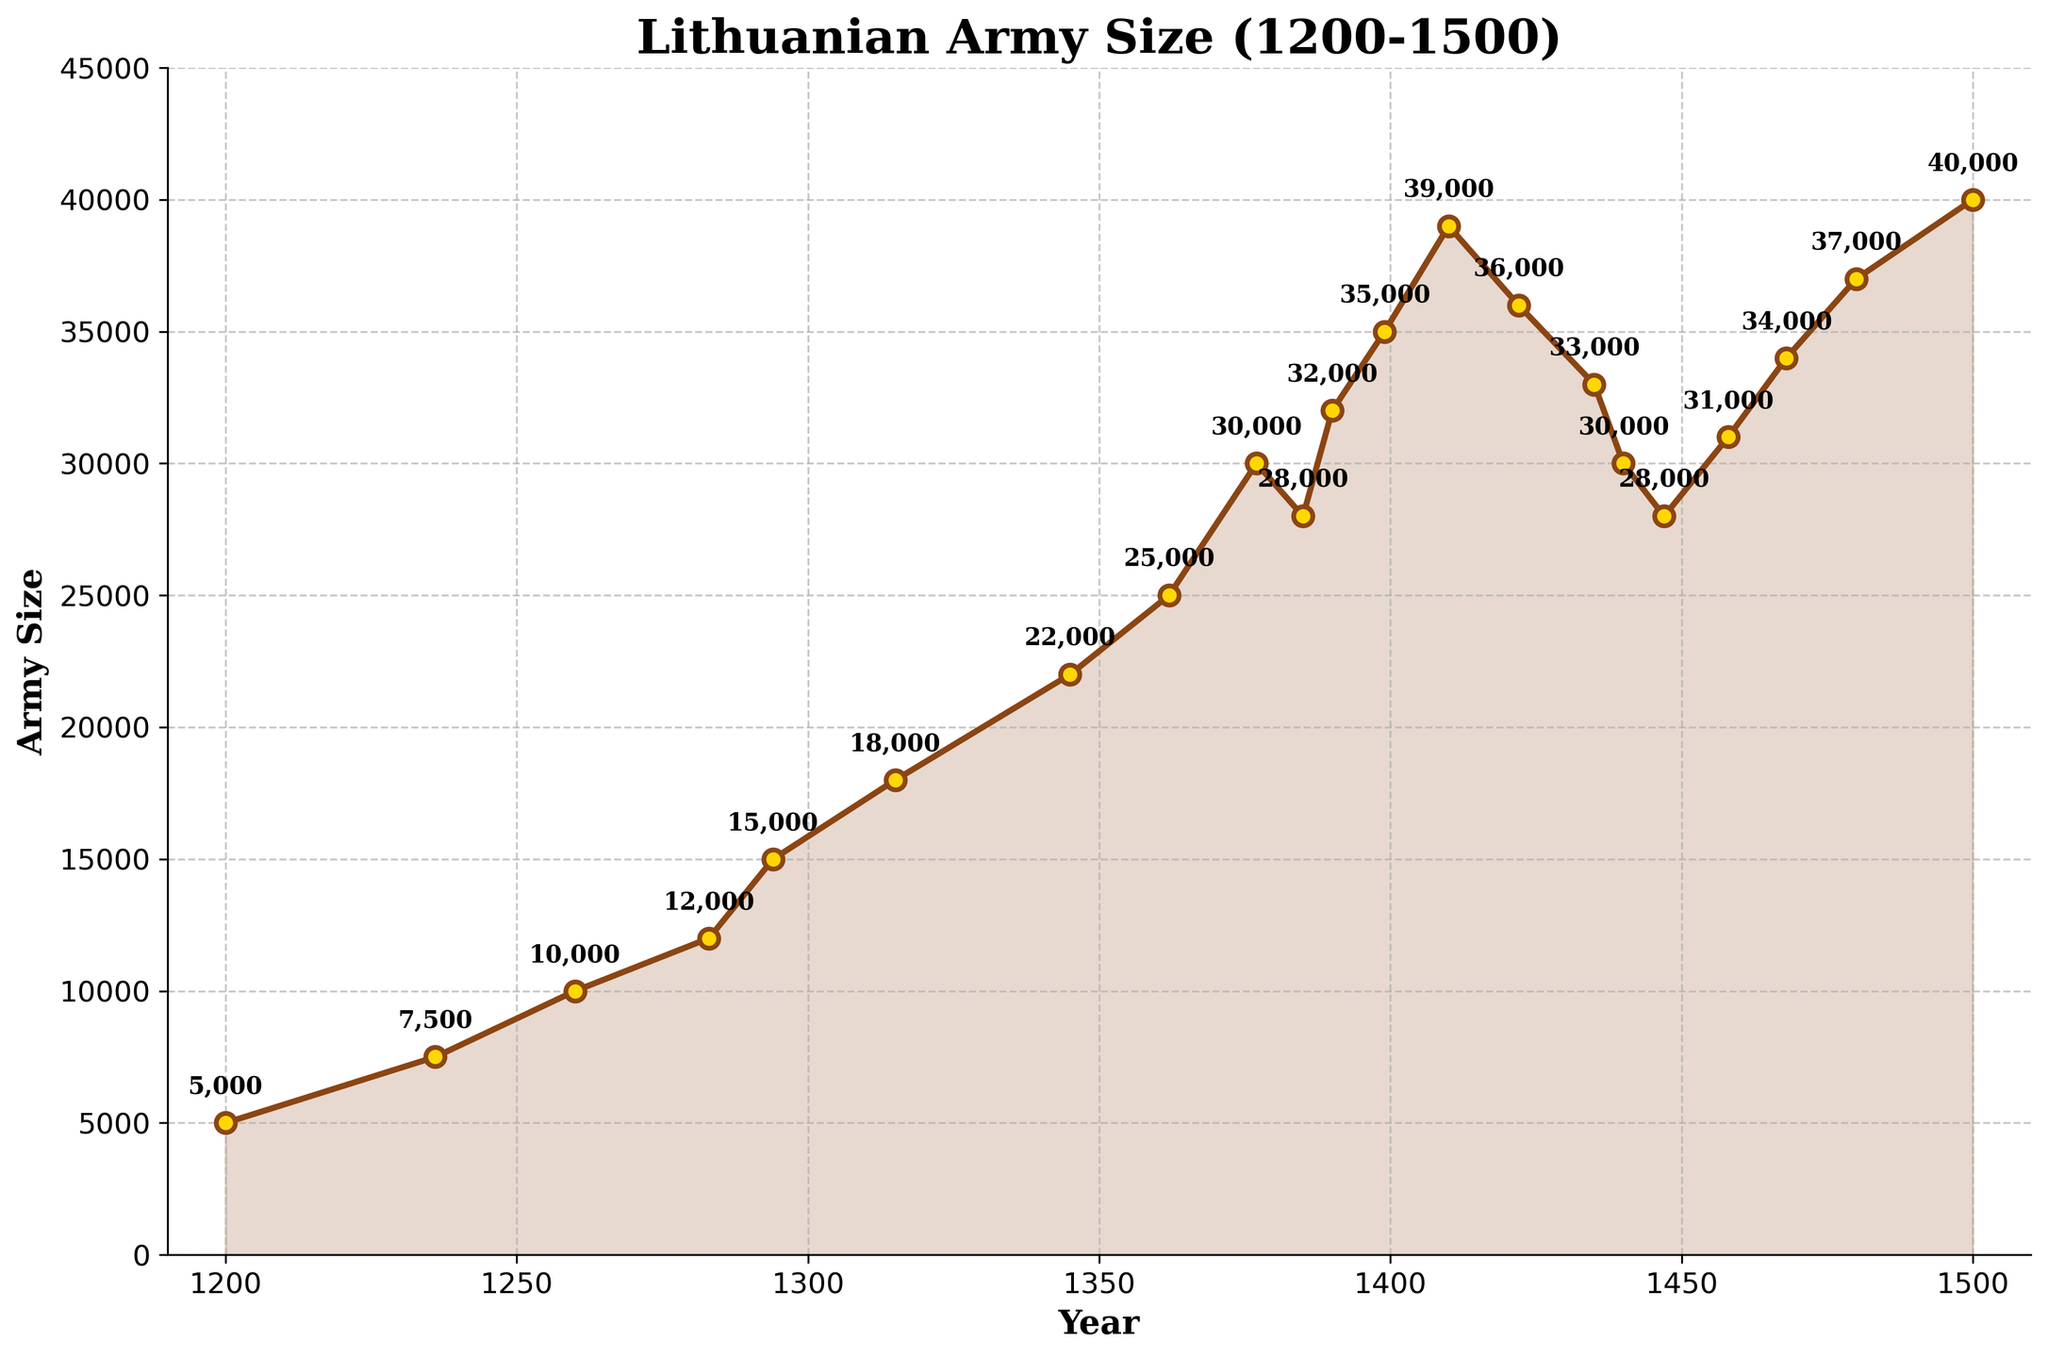What is the trend of the Lithuanian army size from 1200 to 1500? The figure shows a general upward trend in the size of the Lithuanian army from 1200 to 1500, with some fluctuations. The army size increases steadily from 1200 to a peak around 1410, followed by a slight decline and some fluctuations, and then another increase towards 1500.
Answer: The trend is generally upward with fluctuations What year did the Lithuanian army size reach 30,000 for the first time? Referring to the figure, the army size first reaches 30,000 in the year 1377. The data marked for 1377 is 30,000.
Answer: 1377 Between which two years did the Lithuanian army size see the largest increase? By examining the differences year by year, the largest increase occurs between 1385 and 1390, as the army grows from 28,000 to 32,000, an increase of 4,000.
Answer: 1385 and 1390 What is the difference in army size between 1260 and 1345? The army size in 1260 is 10,000, and in 1345, it is 22,000. The difference is 22,000 - 10,000 = 12,000.
Answer: 12,000 In which years did the Lithuanian army experience a decline in its size? By looking at the marked data points that decrease relative to the previous year, the Lithuanian army experienced declines in 1385, 1422, 1435, 1440, and 1447.
Answer: 1385, 1422, 1435, 1440, 1447 How does the army size in 1500 compare to the size in 1200? The army size in 1500 is 40,000 while in 1200 it is 5,000. There is an increase of 40,000 - 5,000 = 35,000.
Answer: The size in 1500 is 35,000 larger than in 1200 What is the average size of the army between 1300 and 1400? The relevant data points are: 1315 (18,000), 1345 (22,000), 1362 (25,000), 1377 (30,000), and 1390 (32,000). The average is (18,000 + 22,000 + 25,000 + 30,000 + 32,000) / 5 = 127,000 / 5 = 25,400.
Answer: 25,400 How did the army size change between 1410 and 1440? In 1410, the army size was 39,000, and by 1440, it had decreased to 30,000. The change is 30,000 - 39,000 = -9,000.
Answer: Decreased by 9,000 Which year shows the highest recorded size of the Lithuanian army? Referencing the data points on the figure, the highest recorded size is in 1500 at 40,000 soldiers.
Answer: 1500 